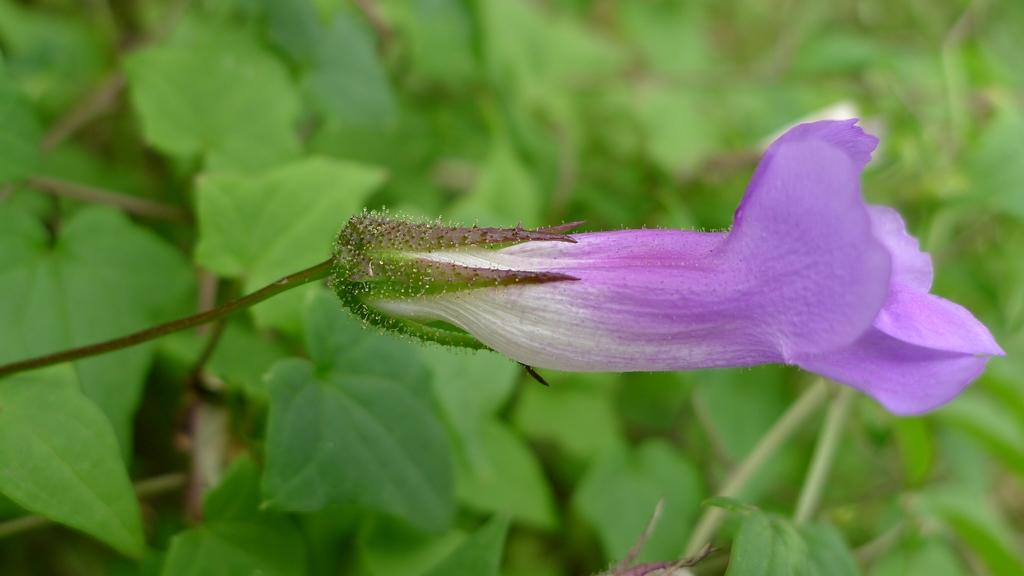What type of plant is in the image? There is a flower with a stem in the image. How is the background of the image depicted? The background of the image has a blurred view. What type of environment is visible in the image? There is greenery visible in the image. What historical event is depicted in the image? There is no historical event depicted in the image; it features a flower with a stem and a blurred background. 